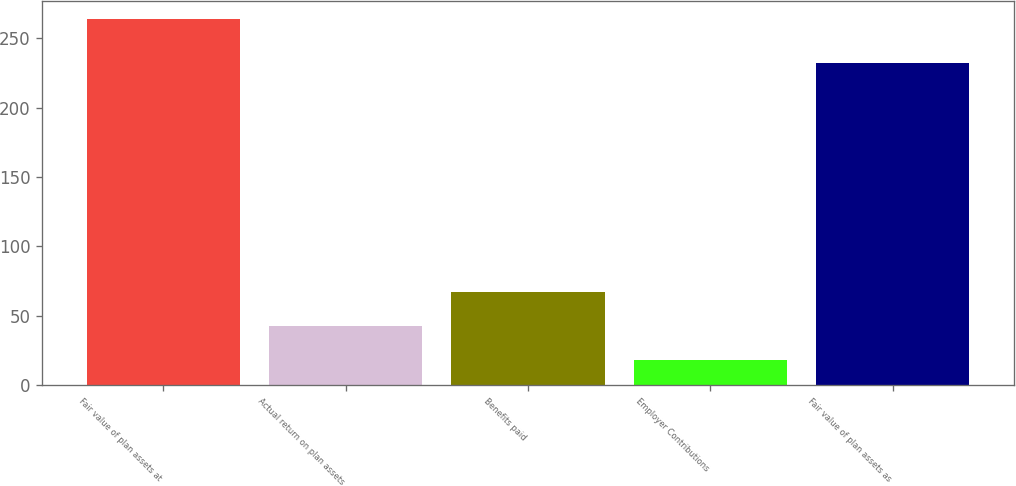Convert chart. <chart><loc_0><loc_0><loc_500><loc_500><bar_chart><fcel>Fair value of plan assets at<fcel>Actual return on plan assets<fcel>Benefits paid<fcel>Employer Contributions<fcel>Fair value of plan assets as<nl><fcel>264<fcel>42.6<fcel>67.2<fcel>18<fcel>232<nl></chart> 